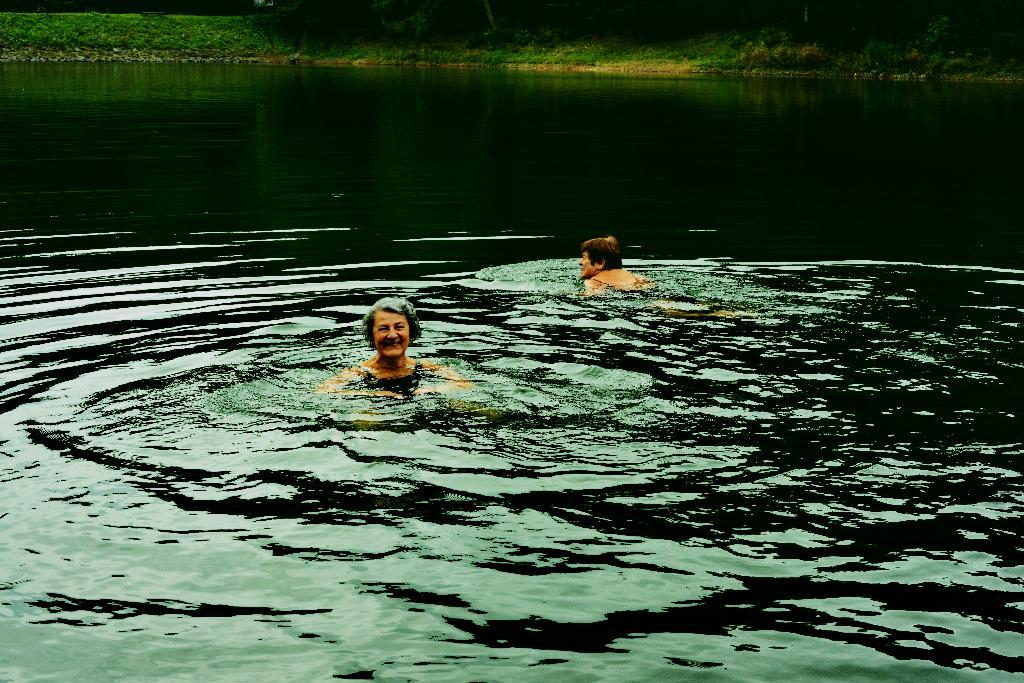How many people are in the water in the image? There are two persons in the water in the image. What can be seen in the background of the image? There is a greenery ground in the background of the image. Can you see a cow with a crook and a crown in the image? No, there is no cow, crook, or crown present in the image. 